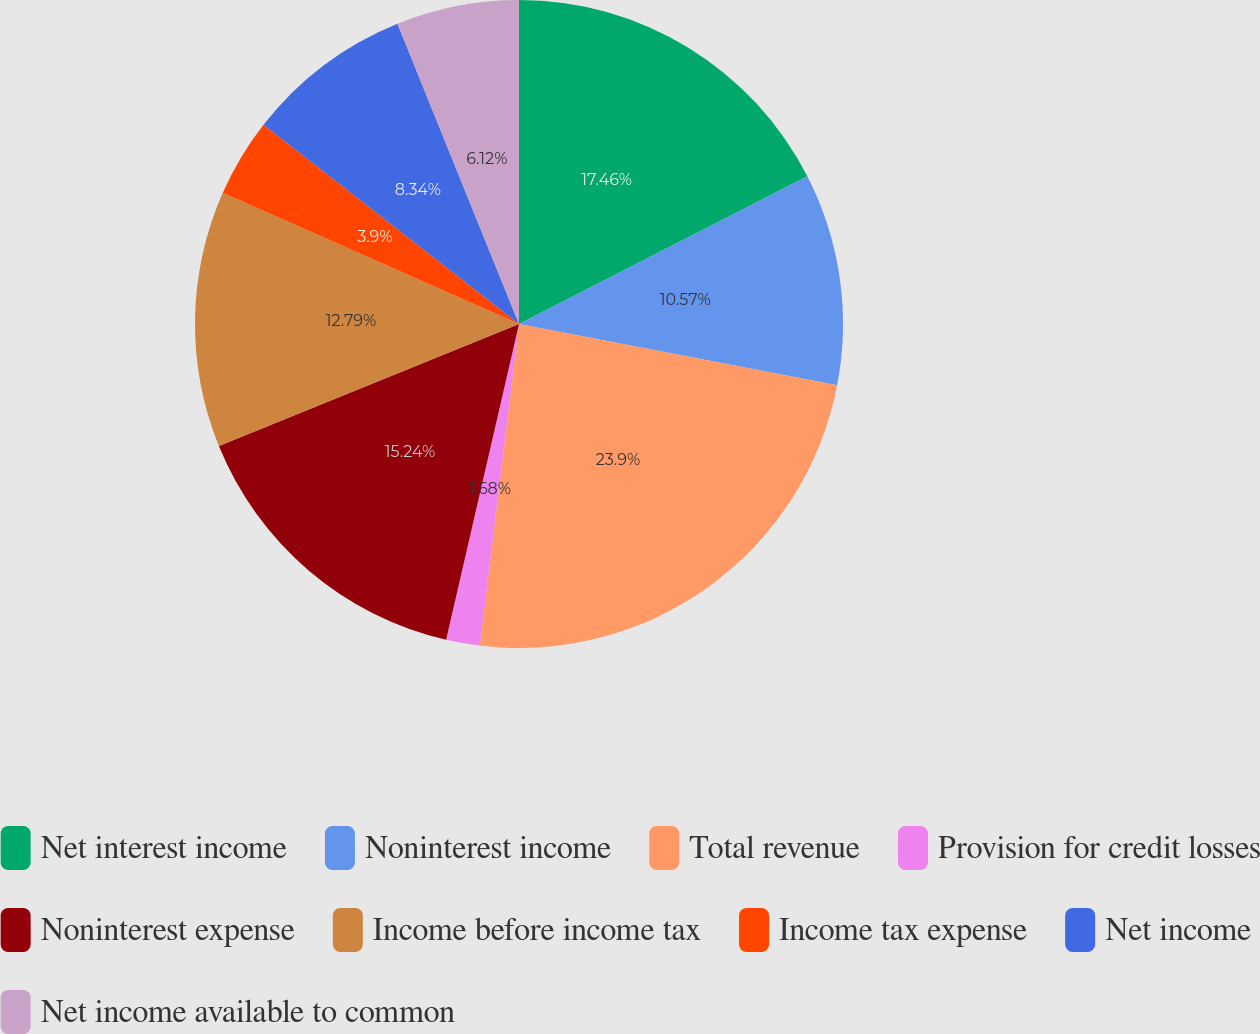<chart> <loc_0><loc_0><loc_500><loc_500><pie_chart><fcel>Net interest income<fcel>Noninterest income<fcel>Total revenue<fcel>Provision for credit losses<fcel>Noninterest expense<fcel>Income before income tax<fcel>Income tax expense<fcel>Net income<fcel>Net income available to common<nl><fcel>17.46%<fcel>10.57%<fcel>23.9%<fcel>1.68%<fcel>15.24%<fcel>12.79%<fcel>3.9%<fcel>8.34%<fcel>6.12%<nl></chart> 